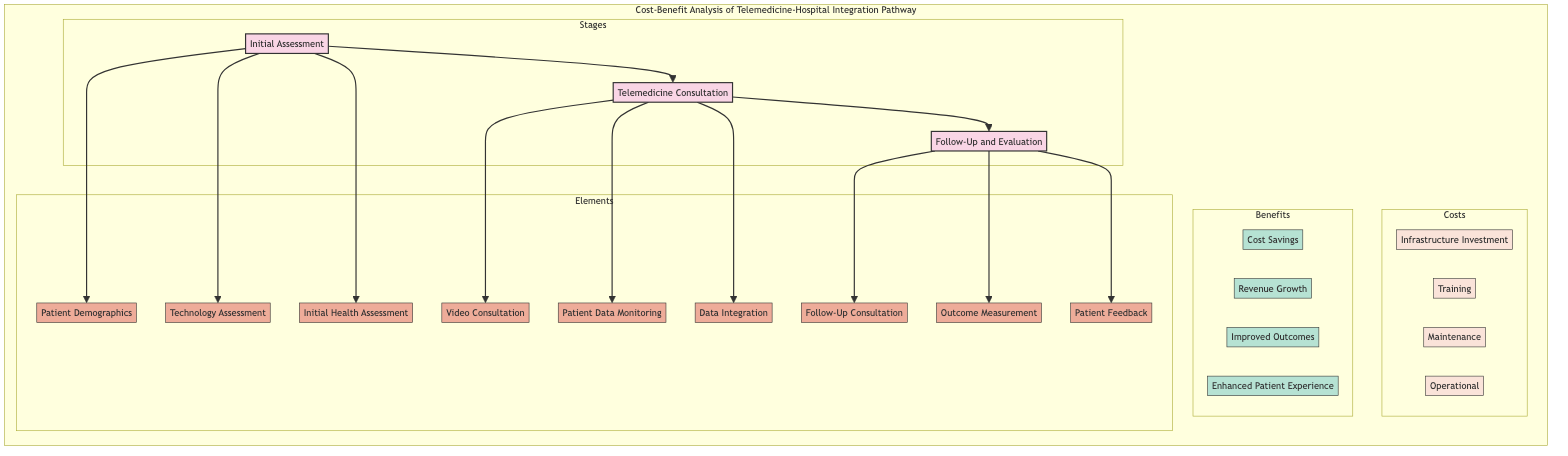What are the three main stages in this pathway? The diagram clearly outlines three main stages: Initial Assessment, Telemedicine Consultation, and Follow-Up and Evaluation.
Answer: Initial Assessment, Telemedicine Consultation, Follow-Up and Evaluation How many benefits are listed in the pathway? In the benefits section of the diagram, there are four benefits identified: Cost Savings, Revenue Growth, Improved Outcomes, and Enhanced Patient Experience.
Answer: Four What element in the Initial Assessment involves medical records? The element related to medical records in the Initial Assessment stage is Patient Demographics, which uses Electronic Health Records.
Answer: Patient Demographics Which stage includes the element Video Consultation? The element Video Consultation is part of the Telemedicine Consultation stage, where various interactions occur through video.
Answer: Telemedicine Consultation What is the financial benefit that focuses on patient retention? The financial benefit related to patient retention is Revenue Growth, which emphasizes increased patient reach and retention strategies.
Answer: Revenue Growth What are the two recurring costs listed in the pathway? The recurring costs in the pathway comprise Maintenance and Operational costs, which address ongoing expenses necessary for the telemedicine system.
Answer: Maintenance, Operational Which element in Follow-Up and Evaluation is directly linked to patient feedback? In the Follow-Up and Evaluation stage, the element that directly pertains to patient feedback is Patient Feedback, which gathers input from patients on their experiences.
Answer: Patient Feedback Which initial cost involves training programs for staff? The initial cost that includes training programs for staff is labeled as Training, aimed at preparing personnel for telemedicine operations.
Answer: Training What is the primary entity responsible for patient data monitoring? The primary entity responsible for patient data monitoring is Remote Monitoring Devices, which collect vital signs and track symptoms during consultations.
Answer: Remote Monitoring Devices What is the main goal of the Initial Health Assessment element? The main goal of the Initial Health Assessment element is to evaluate the patient's vital signs such as blood pressure, heart rate, and BMI.
Answer: Evaluate vital signs 